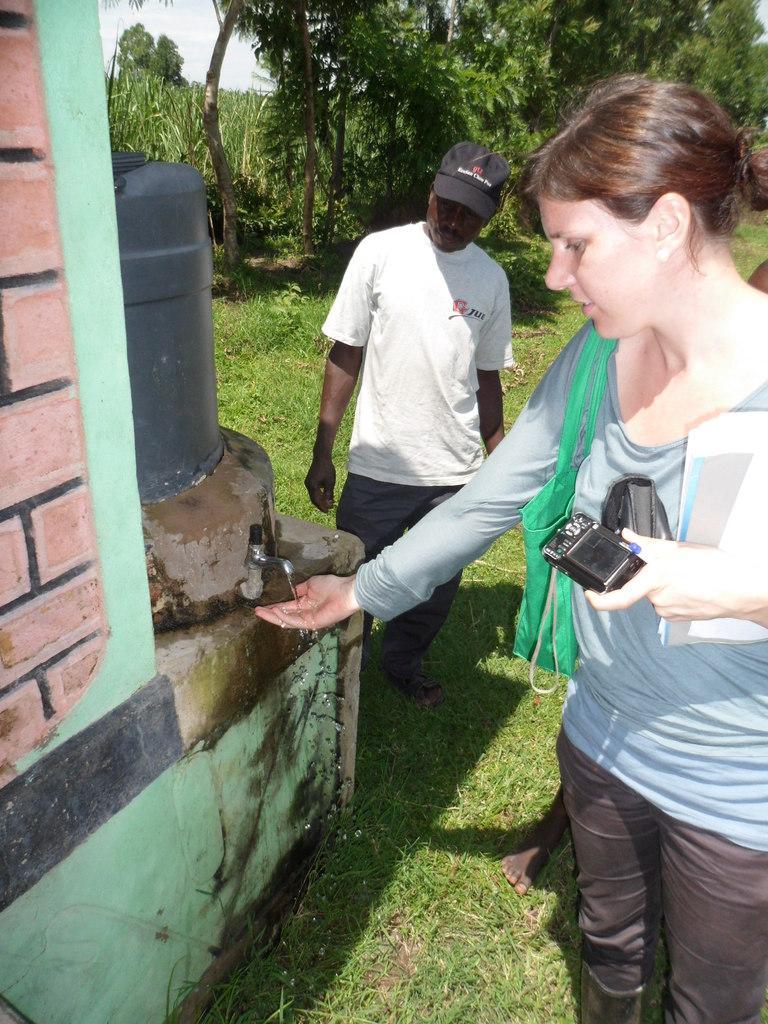Describe this image in one or two sentences. In this image we can see people, wall, water, tap, water tank, and grass. In the background there are trees and sky. 